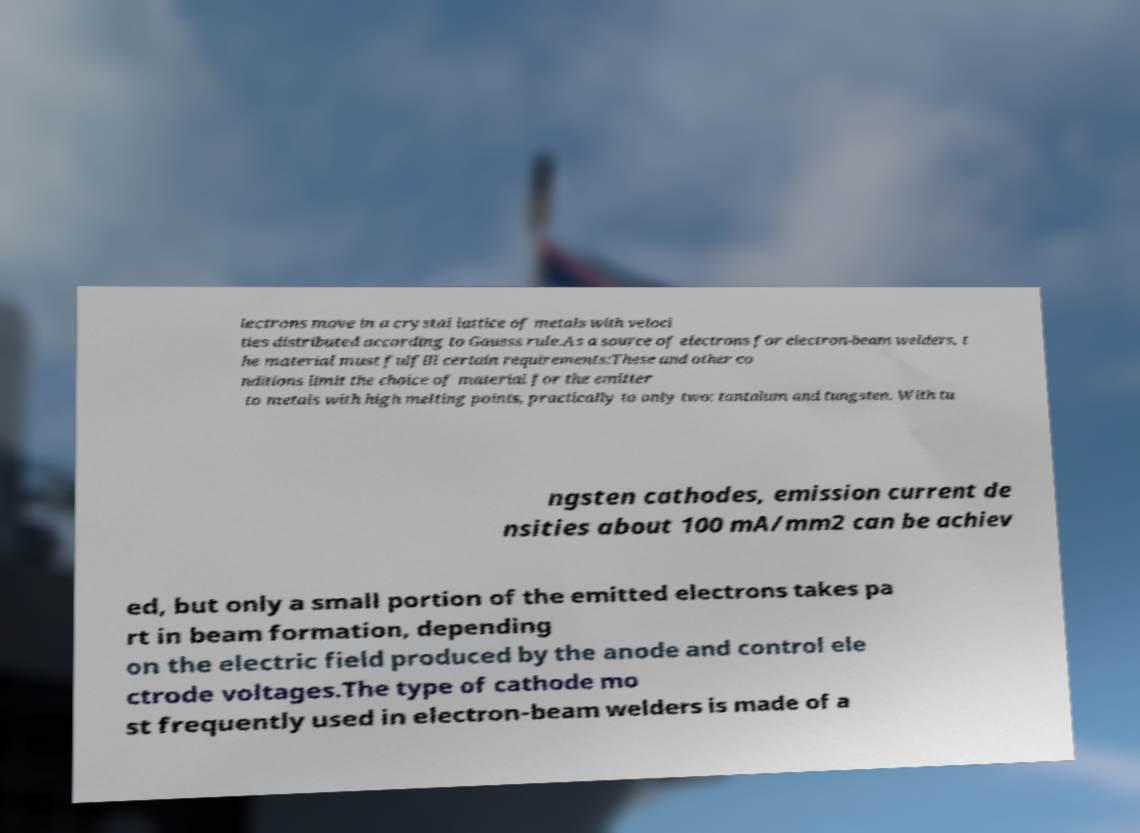For documentation purposes, I need the text within this image transcribed. Could you provide that? lectrons move in a crystal lattice of metals with veloci ties distributed according to Gausss rule.As a source of electrons for electron-beam welders, t he material must fulfill certain requirements:These and other co nditions limit the choice of material for the emitter to metals with high melting points, practically to only two: tantalum and tungsten. With tu ngsten cathodes, emission current de nsities about 100 mA/mm2 can be achiev ed, but only a small portion of the emitted electrons takes pa rt in beam formation, depending on the electric field produced by the anode and control ele ctrode voltages.The type of cathode mo st frequently used in electron-beam welders is made of a 